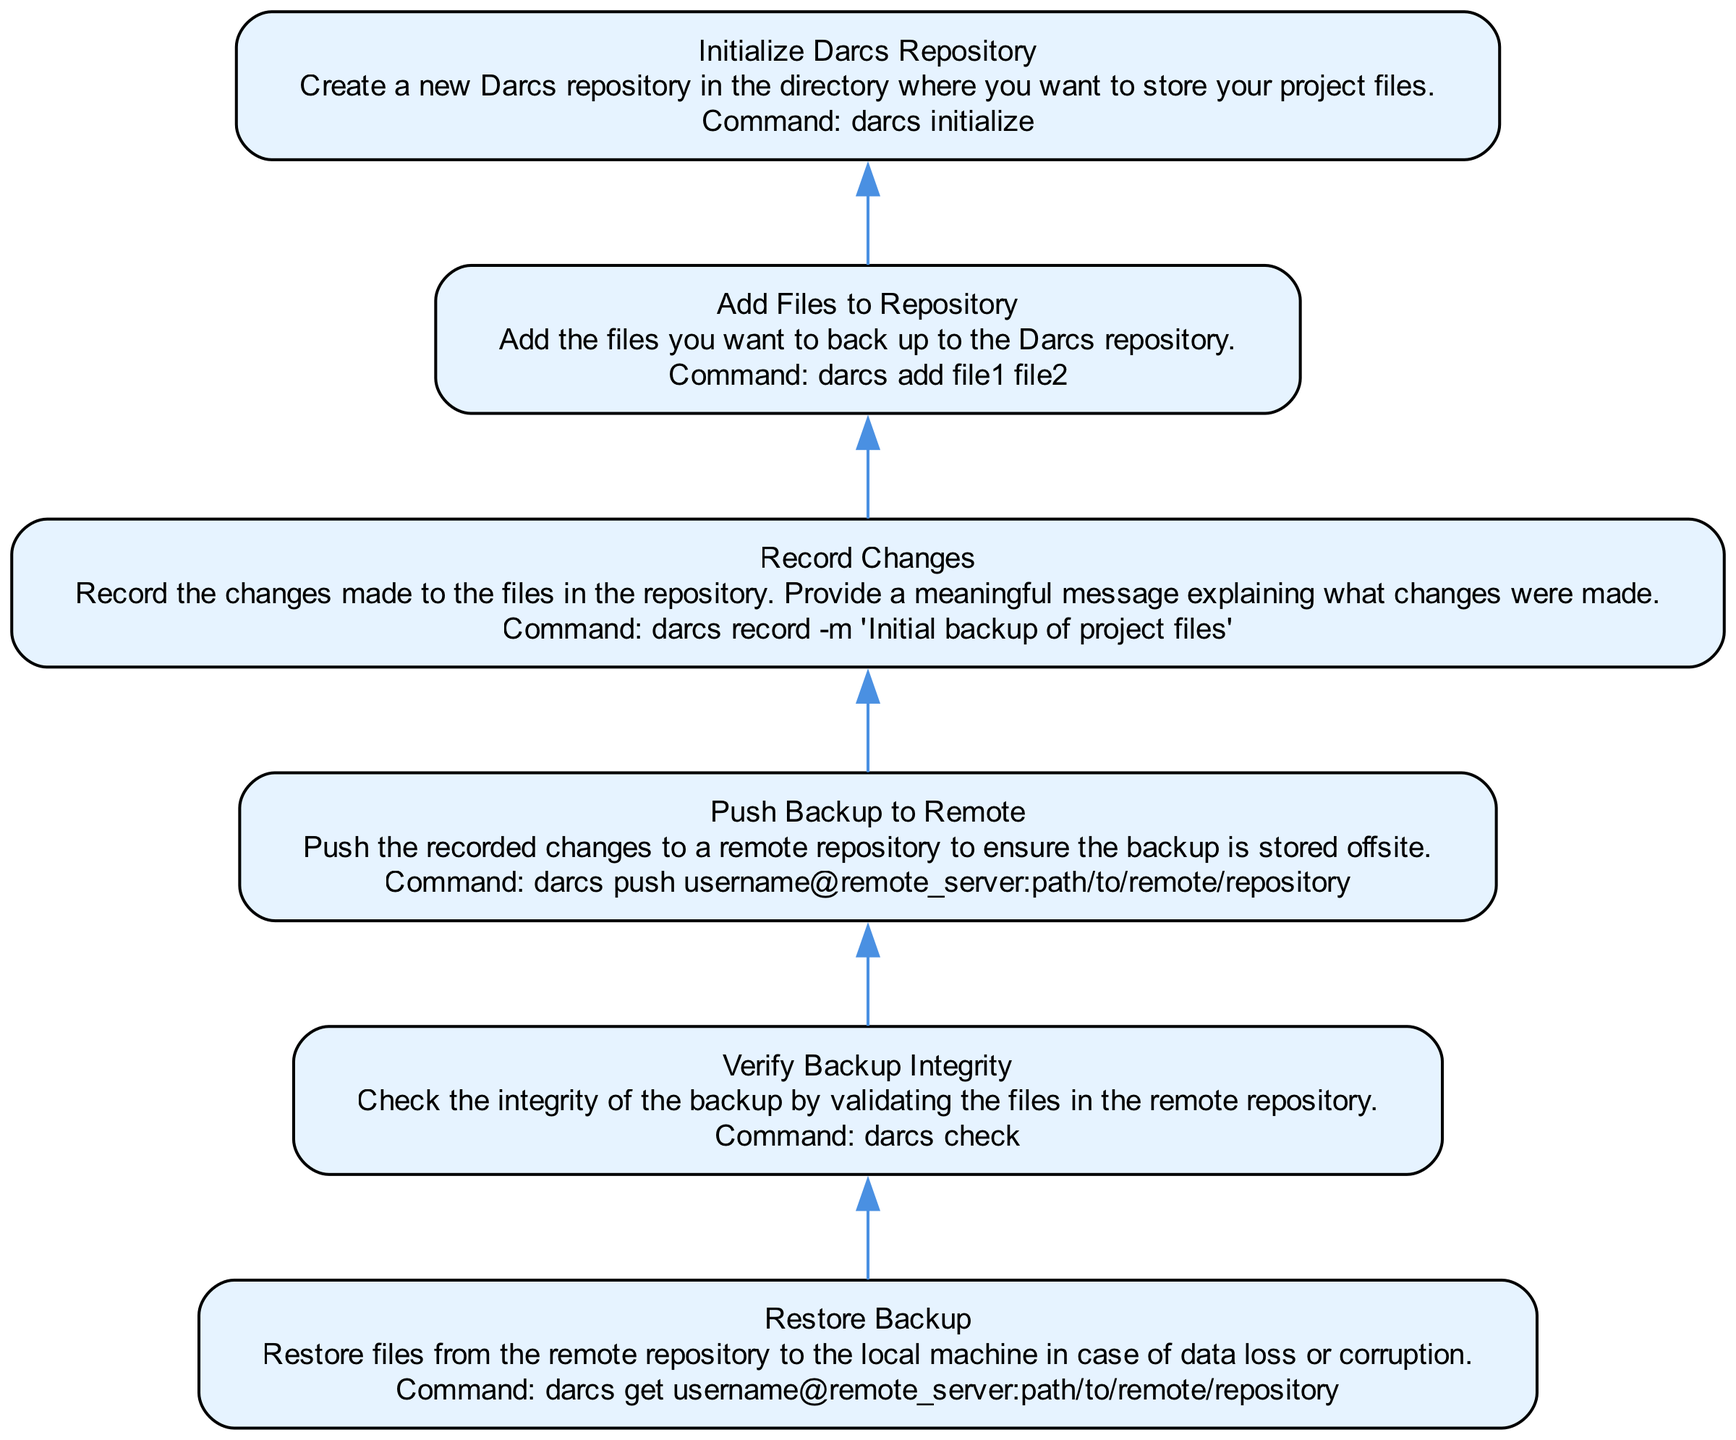What is the first step in the backup process? The first step, as seen in the bottom node of the diagram, is to "Initialize Darcs Repository," which is essential to create a new repository in the desired directory.
Answer: Initialize Darcs Repository How many nodes are present in the diagram? Counting the nodes from the bottom to the top, there are a total of six distinct steps, or nodes, shown in the diagram.
Answer: 6 What command is associated with recording changes? The node related to recording changes provides the command "darcs record -m 'Initial backup of project files'" which clearly states what action is taken with this command.
Answer: darcs record -m 'Initial backup of project files' What is the last step in restoring data? The last step in the diagram indicates that the process completes with the "Restore Backup," which explains how to recover files from the remote repository.
Answer: Restore Backup Which two steps directly precede the verification of backup integrity? The steps that come directly before verifying backup integrity are "Push Backup to Remote" and "Record Changes," as they ensure the recorded changes are sent offsite before integrity checking.
Answer: Push Backup to Remote and Record Changes What is verified after pushing the backup? After pushing the backup, the next step is to "Verify Backup Integrity," which checks if the backup stored remotely is intact and valid.
Answer: Verify Backup Integrity Explain the flow from adding files to restoring backup. The sequence begins with "Add Files to Repository," where files are added to be backed up. This is followed by "Record Changes," which logs those additions. Next, the backup is sent offsite by "Push Backup to Remote." After that, "Verify Backup Integrity" ensures that the remote backup is accurate, and finally, in case of data loss, one can perform the "Restore Backup." Thus, the flow covers adding, recording, pushing, verifying, and restoring steps.
Answer: Add, Record, Push, Verify, Restore What is the command for adding files to the repository? According to the node for adding files, the relevant command is "darcs add file1 file2," which specifies how to include files into the repository.
Answer: darcs add file1 file2 What action is taken when the backup needs to be restored? The action taken when restoring the backup is to execute the command "darcs get username@remote_server:path/to/remote/repository" to retrieve the files back to the local machine.
Answer: darcs get username@remote_server:path/to/remote/repository 